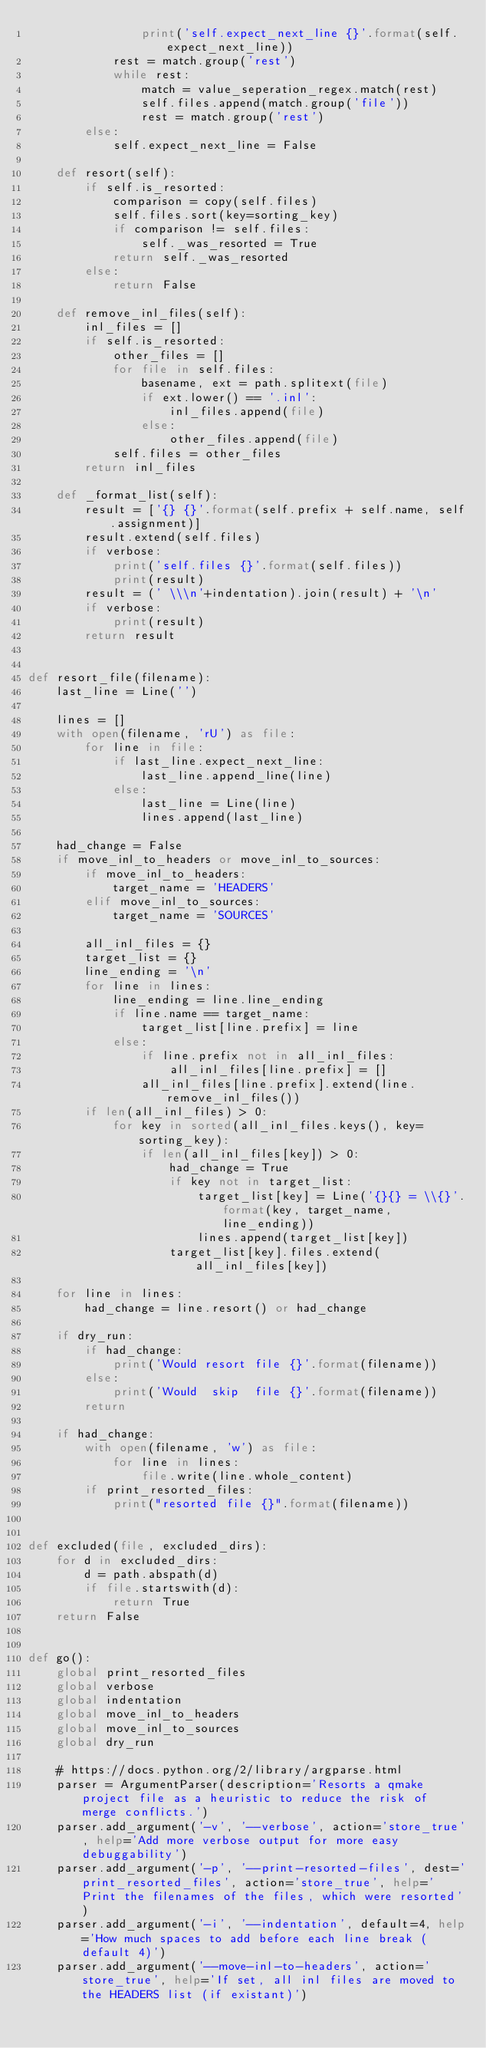Convert code to text. <code><loc_0><loc_0><loc_500><loc_500><_Python_>                print('self.expect_next_line {}'.format(self.expect_next_line))
            rest = match.group('rest')
            while rest:
                match = value_seperation_regex.match(rest)
                self.files.append(match.group('file'))
                rest = match.group('rest')
        else:
            self.expect_next_line = False

    def resort(self):
        if self.is_resorted:
            comparison = copy(self.files)
            self.files.sort(key=sorting_key)
            if comparison != self.files:
                self._was_resorted = True
            return self._was_resorted
        else:
            return False

    def remove_inl_files(self):
        inl_files = []
        if self.is_resorted:
            other_files = []
            for file in self.files:
                basename, ext = path.splitext(file)
                if ext.lower() == '.inl':
                    inl_files.append(file)
                else:
                    other_files.append(file)
            self.files = other_files
        return inl_files

    def _format_list(self):
        result = ['{} {}'.format(self.prefix + self.name, self.assignment)]
        result.extend(self.files)
        if verbose:
            print('self.files {}'.format(self.files))
            print(result)
        result = (' \\\n'+indentation).join(result) + '\n'
        if verbose:
            print(result)
        return result


def resort_file(filename):
    last_line = Line('')

    lines = []
    with open(filename, 'rU') as file:
        for line in file:
            if last_line.expect_next_line:
                last_line.append_line(line)
            else:
                last_line = Line(line)
                lines.append(last_line)

    had_change = False
    if move_inl_to_headers or move_inl_to_sources:
        if move_inl_to_headers:
            target_name = 'HEADERS'
        elif move_inl_to_sources:
            target_name = 'SOURCES'

        all_inl_files = {}
        target_list = {}
        line_ending = '\n'
        for line in lines:
            line_ending = line.line_ending
            if line.name == target_name:
                target_list[line.prefix] = line
            else:
                if line.prefix not in all_inl_files:
                    all_inl_files[line.prefix] = []
                all_inl_files[line.prefix].extend(line.remove_inl_files())
        if len(all_inl_files) > 0:
            for key in sorted(all_inl_files.keys(), key=sorting_key):
                if len(all_inl_files[key]) > 0:
                    had_change = True
                    if key not in target_list:
                        target_list[key] = Line('{}{} = \\{}'.format(key, target_name, line_ending))
                        lines.append(target_list[key])
                    target_list[key].files.extend(all_inl_files[key])

    for line in lines:
        had_change = line.resort() or had_change

    if dry_run:
        if had_change:
            print('Would resort file {}'.format(filename))
        else:
            print('Would  skip  file {}'.format(filename))
        return

    if had_change:
        with open(filename, 'w') as file:
            for line in lines:
                file.write(line.whole_content)
        if print_resorted_files:
            print("resorted file {}".format(filename))


def excluded(file, excluded_dirs):
    for d in excluded_dirs:
        d = path.abspath(d)
        if file.startswith(d):
            return True
    return False


def go():
    global print_resorted_files
    global verbose
    global indentation
    global move_inl_to_headers
    global move_inl_to_sources
    global dry_run

    # https://docs.python.org/2/library/argparse.html
    parser = ArgumentParser(description='Resorts a qmake project file as a heuristic to reduce the risk of merge conflicts.')
    parser.add_argument('-v', '--verbose', action='store_true', help='Add more verbose output for more easy debuggability')
    parser.add_argument('-p', '--print-resorted-files', dest='print_resorted_files', action='store_true', help='Print the filenames of the files, which were resorted')
    parser.add_argument('-i', '--indentation', default=4, help='How much spaces to add before each line break (default 4)')
    parser.add_argument('--move-inl-to-headers', action='store_true', help='If set, all inl files are moved to the HEADERS list (if existant)')</code> 